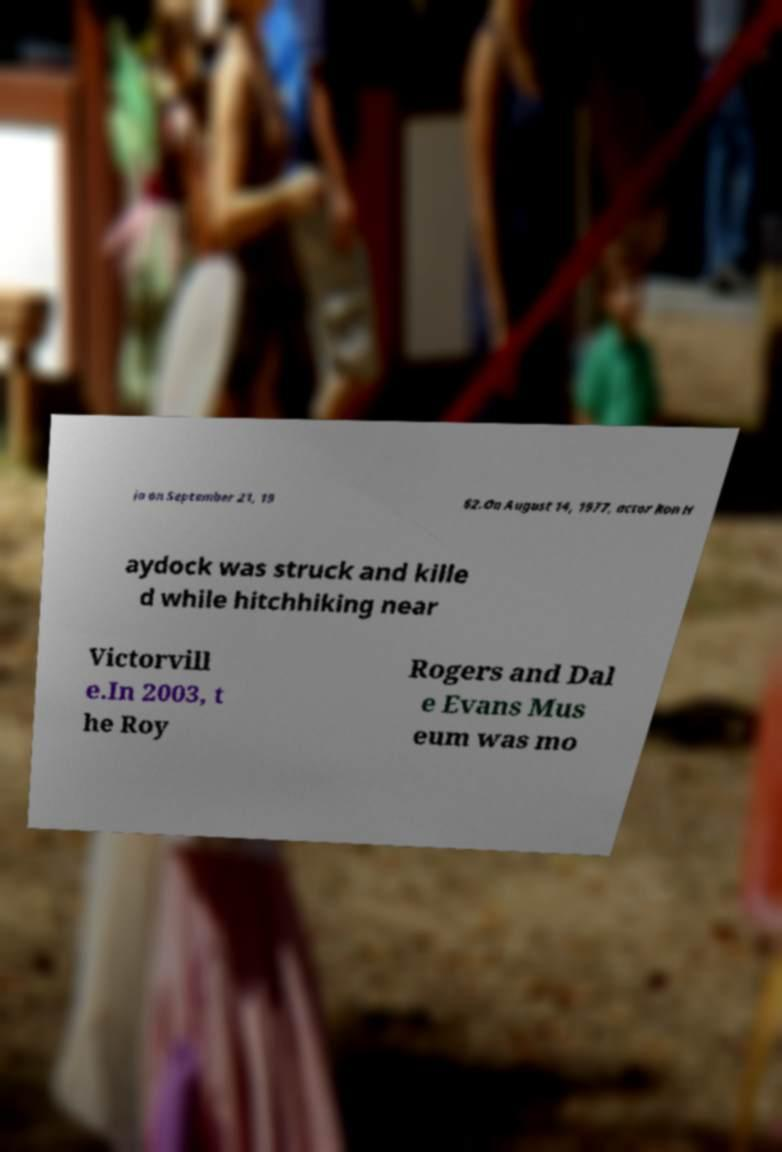What messages or text are displayed in this image? I need them in a readable, typed format. ia on September 21, 19 62.On August 14, 1977, actor Ron H aydock was struck and kille d while hitchhiking near Victorvill e.In 2003, t he Roy Rogers and Dal e Evans Mus eum was mo 